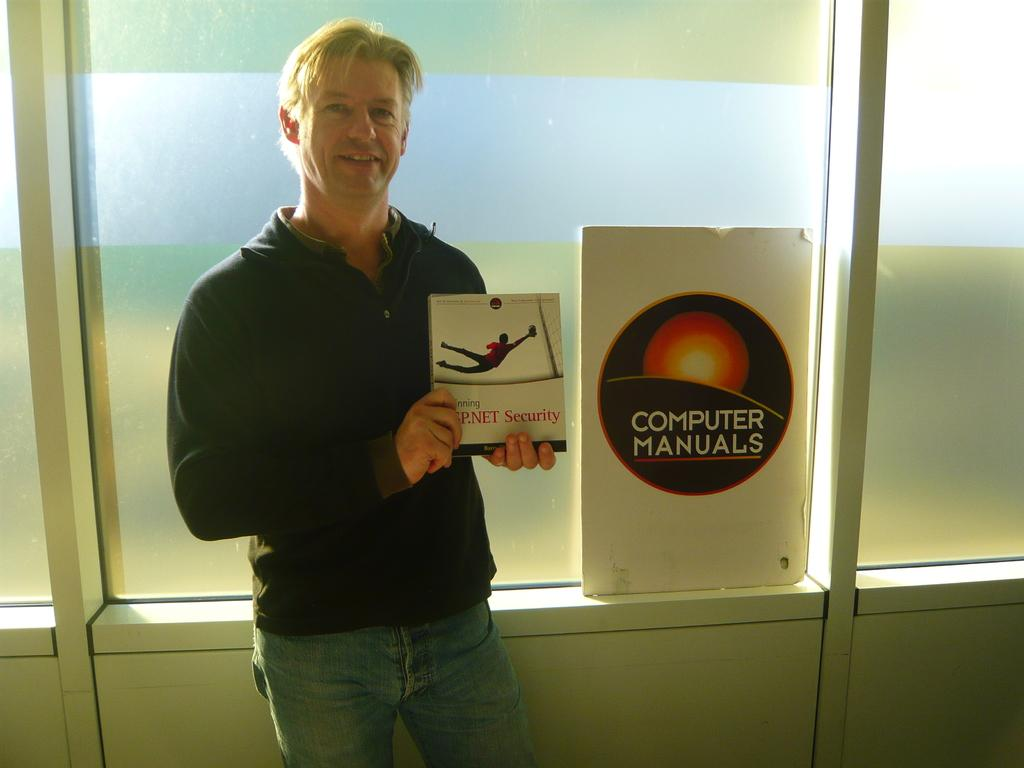<image>
Provide a brief description of the given image. a man holding a book next to a sign for computer manuals 